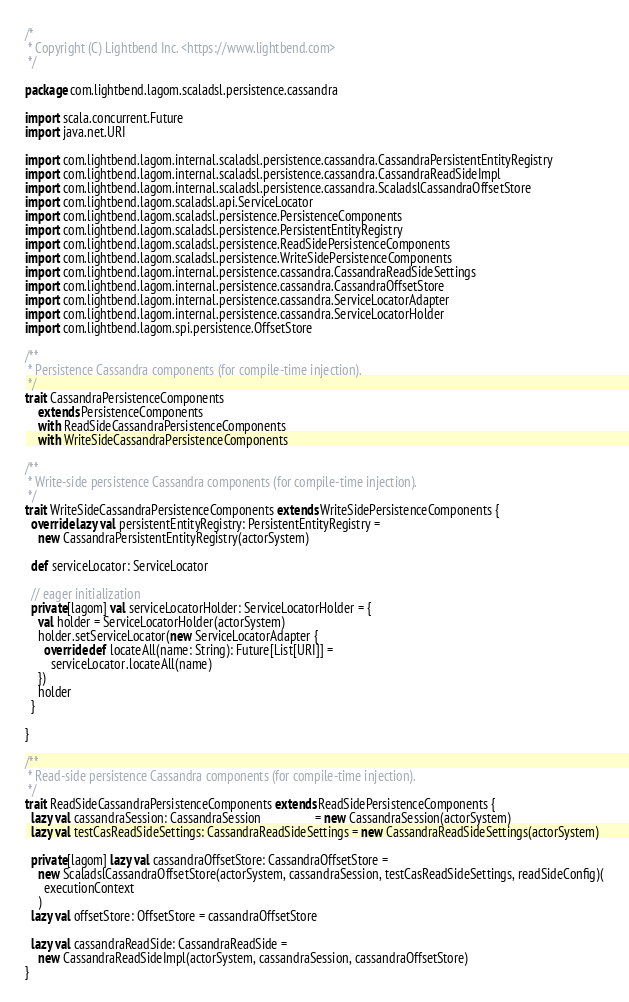<code> <loc_0><loc_0><loc_500><loc_500><_Scala_>/*
 * Copyright (C) Lightbend Inc. <https://www.lightbend.com>
 */

package com.lightbend.lagom.scaladsl.persistence.cassandra

import scala.concurrent.Future
import java.net.URI

import com.lightbend.lagom.internal.scaladsl.persistence.cassandra.CassandraPersistentEntityRegistry
import com.lightbend.lagom.internal.scaladsl.persistence.cassandra.CassandraReadSideImpl
import com.lightbend.lagom.internal.scaladsl.persistence.cassandra.ScaladslCassandraOffsetStore
import com.lightbend.lagom.scaladsl.api.ServiceLocator
import com.lightbend.lagom.scaladsl.persistence.PersistenceComponents
import com.lightbend.lagom.scaladsl.persistence.PersistentEntityRegistry
import com.lightbend.lagom.scaladsl.persistence.ReadSidePersistenceComponents
import com.lightbend.lagom.scaladsl.persistence.WriteSidePersistenceComponents
import com.lightbend.lagom.internal.persistence.cassandra.CassandraReadSideSettings
import com.lightbend.lagom.internal.persistence.cassandra.CassandraOffsetStore
import com.lightbend.lagom.internal.persistence.cassandra.ServiceLocatorAdapter
import com.lightbend.lagom.internal.persistence.cassandra.ServiceLocatorHolder
import com.lightbend.lagom.spi.persistence.OffsetStore

/**
 * Persistence Cassandra components (for compile-time injection).
 */
trait CassandraPersistenceComponents
    extends PersistenceComponents
    with ReadSideCassandraPersistenceComponents
    with WriteSideCassandraPersistenceComponents

/**
 * Write-side persistence Cassandra components (for compile-time injection).
 */
trait WriteSideCassandraPersistenceComponents extends WriteSidePersistenceComponents {
  override lazy val persistentEntityRegistry: PersistentEntityRegistry =
    new CassandraPersistentEntityRegistry(actorSystem)

  def serviceLocator: ServiceLocator

  // eager initialization
  private[lagom] val serviceLocatorHolder: ServiceLocatorHolder = {
    val holder = ServiceLocatorHolder(actorSystem)
    holder.setServiceLocator(new ServiceLocatorAdapter {
      override def locateAll(name: String): Future[List[URI]] =
        serviceLocator.locateAll(name)
    })
    holder
  }

}

/**
 * Read-side persistence Cassandra components (for compile-time injection).
 */
trait ReadSideCassandraPersistenceComponents extends ReadSidePersistenceComponents {
  lazy val cassandraSession: CassandraSession                 = new CassandraSession(actorSystem)
  lazy val testCasReadSideSettings: CassandraReadSideSettings = new CassandraReadSideSettings(actorSystem)

  private[lagom] lazy val cassandraOffsetStore: CassandraOffsetStore =
    new ScaladslCassandraOffsetStore(actorSystem, cassandraSession, testCasReadSideSettings, readSideConfig)(
      executionContext
    )
  lazy val offsetStore: OffsetStore = cassandraOffsetStore

  lazy val cassandraReadSide: CassandraReadSide =
    new CassandraReadSideImpl(actorSystem, cassandraSession, cassandraOffsetStore)
}
</code> 